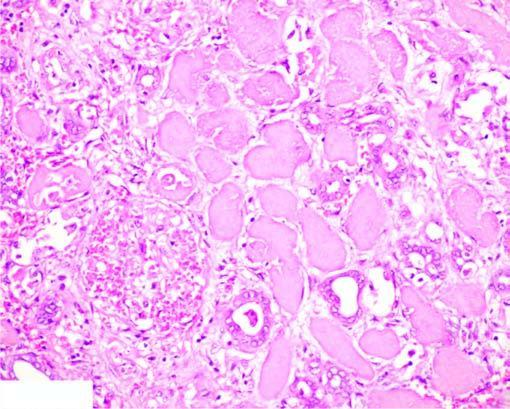what shows non-specific chronic inflammation and proliferating vessels?
Answer the question using a single word or phrase. The interface between viable non-viable area vessels 